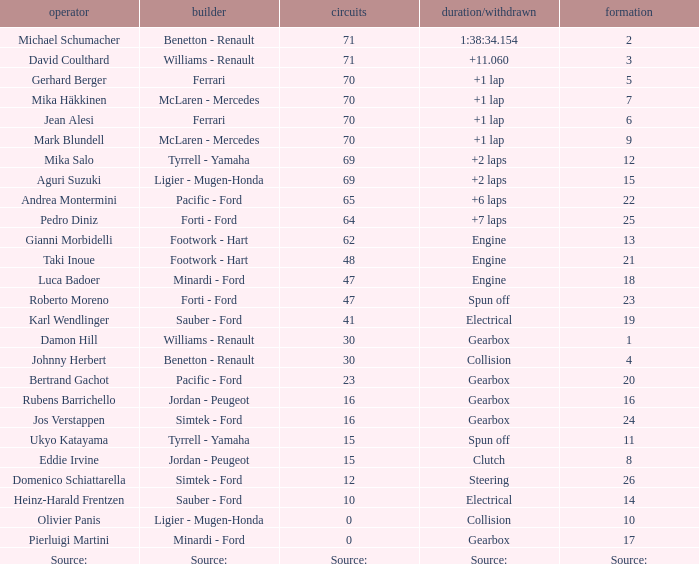How many laps were there in grid 21? 48.0. 